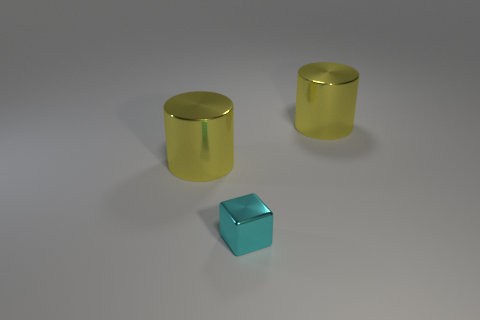What could be the function of these objects if they were part of a larger machine? If these objects were components of a larger machine, the cylinders might serve as pistons or rollers due to their shape, enabling movement or providing structural support. The small block could act as a connector or a mount, securing different parts together based on its solid and symmetrical shape. 